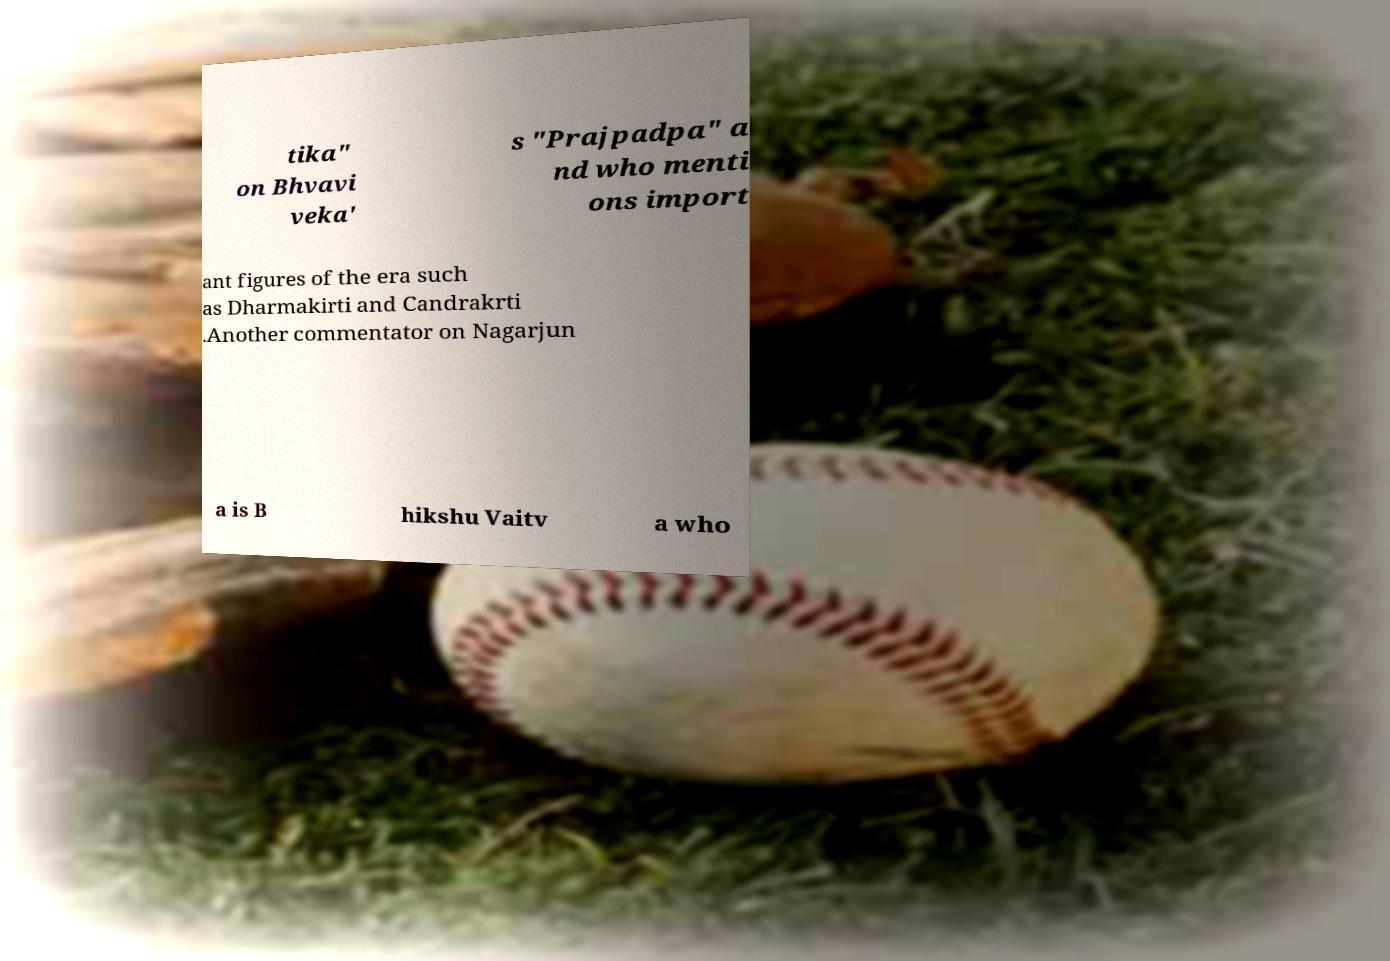Could you extract and type out the text from this image? tika" on Bhvavi veka' s "Prajpadpa" a nd who menti ons import ant figures of the era such as Dharmakirti and Candrakrti .Another commentator on Nagarjun a is B hikshu Vaitv a who 